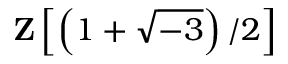<formula> <loc_0><loc_0><loc_500><loc_500>Z \left [ \left ( 1 + { \sqrt { - 3 } } \right ) / 2 \right ]</formula> 